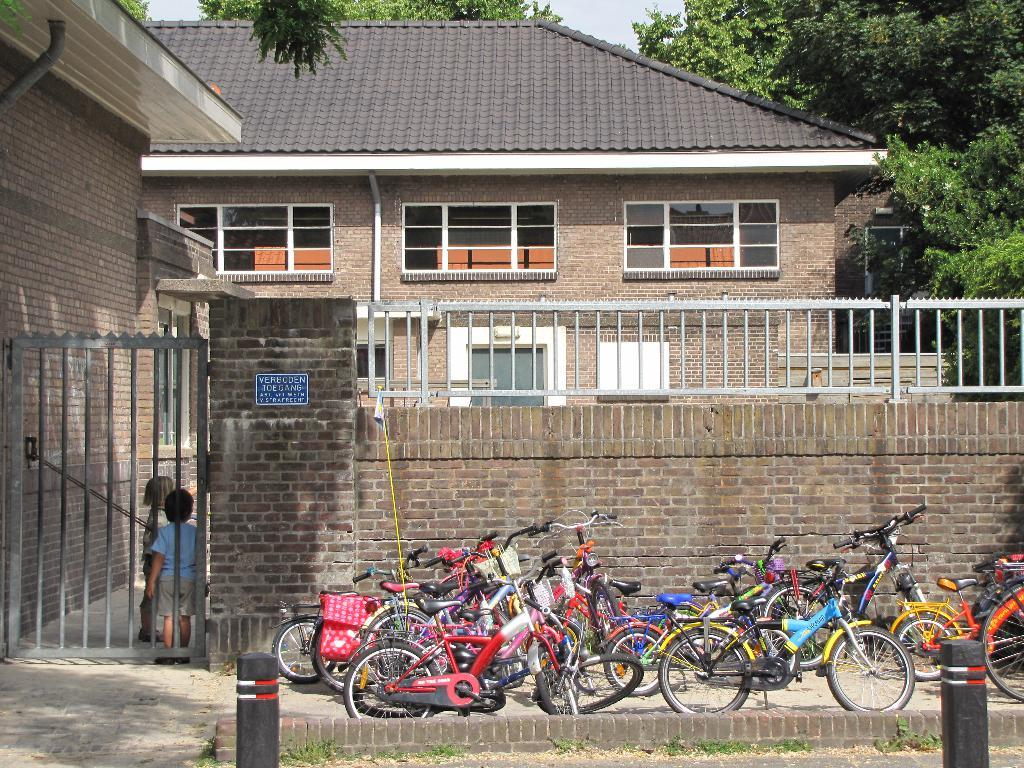What type of structure is visible in the image? There is a building in the image. What feature can be seen on the building? There are windows in the image. Is there any entrance or exit visible in the image? Yes, there is a gate in the image. What type of vegetation is present in the image? There are trees in the image. What mode of transportation can be seen in the image? There are bicycles in the image. How many bicycles are there, and what can be said about their appearance? There are multiple bicycles in the image, and they are in different colors. Are there any people visible in the image? Yes, there are two children standing in the image. What type of owl can be seen perched on the gate in the image? There is no owl present in the image; it features a building, windows, a gate, trees, bicycles, and two children. What type of furniture is visible in the image? There is no furniture visible in the image. 